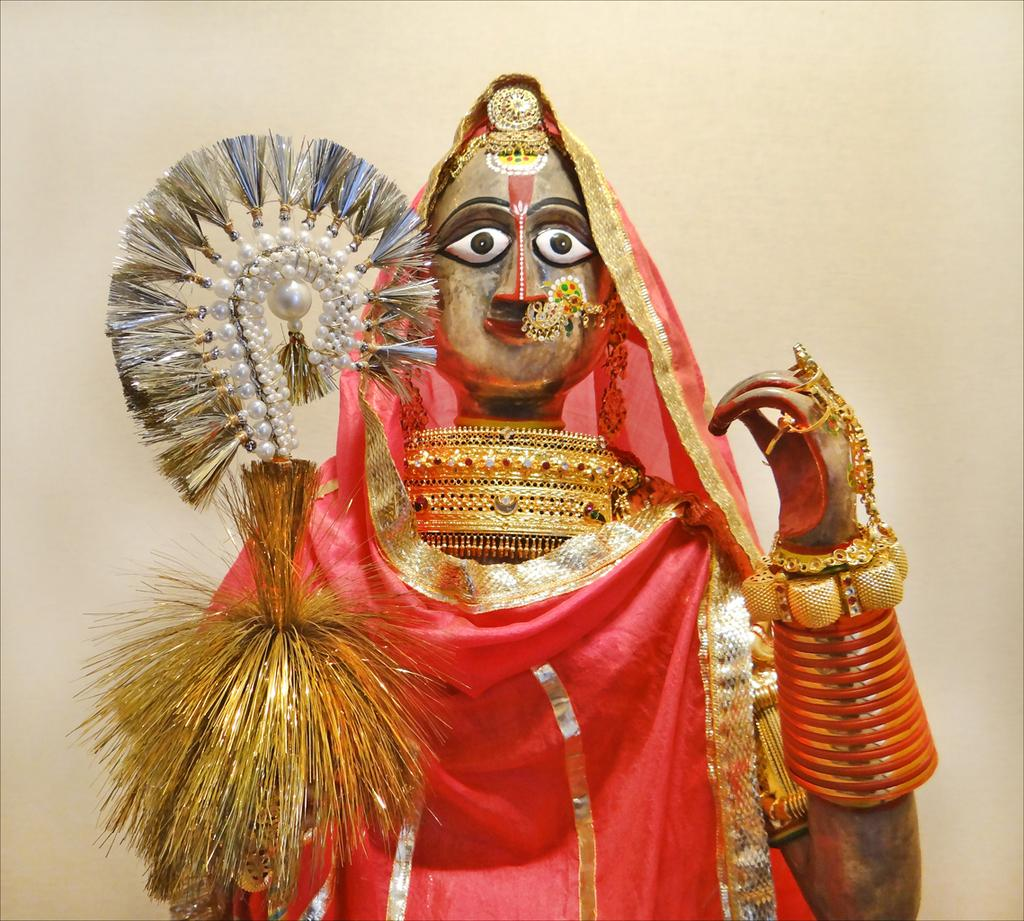What is the main subject in the image? There is a statue in the image. What color is the cloth that is visible in the image? There is a red cloth in the image. What type of decorative items can be seen in the image? There are ornaments and bangles in the image. Can you describe any other objects in the image? There are other objects in the image, but their specific details are not mentioned in the provided facts. What is visible in the background of the image? There is a wall in the background of the image. Can you describe the waves crashing against the chair in the image? There is no chair or waves present in the image; it features a statue, a red cloth, ornaments, bangles, and a wall in the background. 